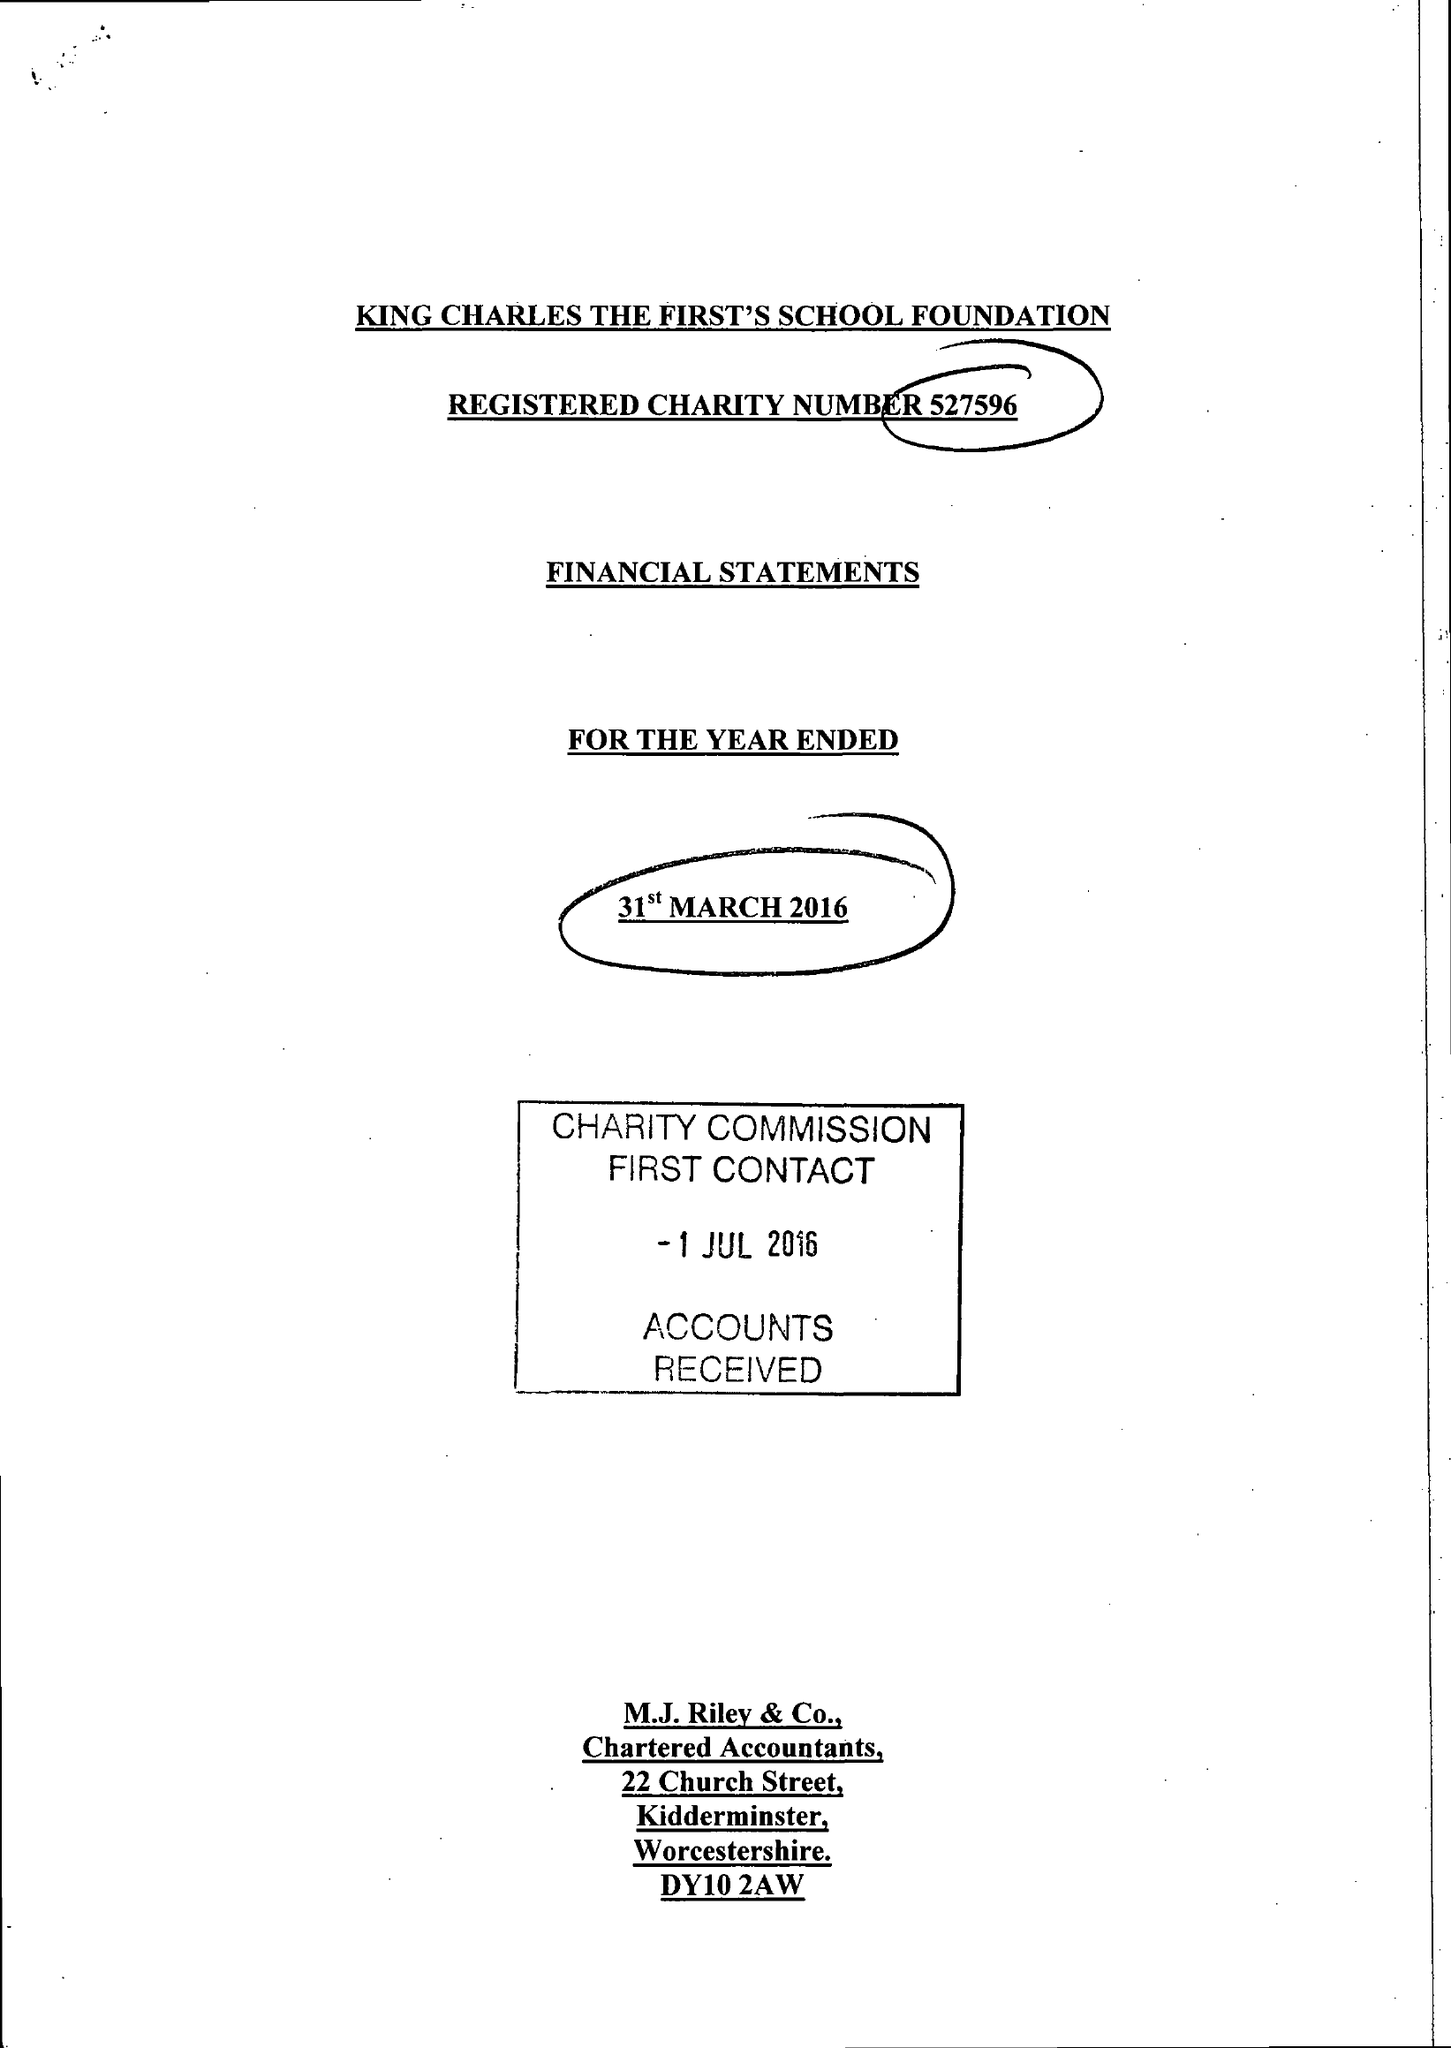What is the value for the income_annually_in_british_pounds?
Answer the question using a single word or phrase. 63860.00 